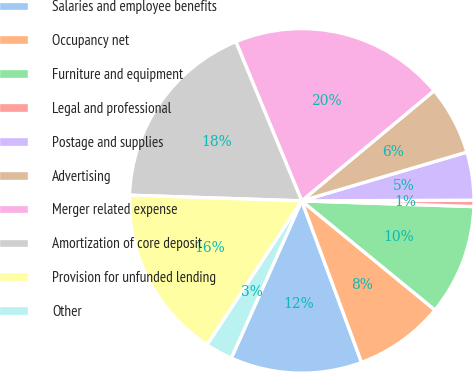Convert chart. <chart><loc_0><loc_0><loc_500><loc_500><pie_chart><fcel>Salaries and employee benefits<fcel>Occupancy net<fcel>Furniture and equipment<fcel>Legal and professional<fcel>Postage and supplies<fcel>Advertising<fcel>Merger related expense<fcel>Amortization of core deposit<fcel>Provision for unfunded lending<fcel>Other<nl><fcel>12.35%<fcel>8.43%<fcel>10.39%<fcel>0.59%<fcel>4.51%<fcel>6.47%<fcel>20.2%<fcel>18.23%<fcel>16.27%<fcel>2.55%<nl></chart> 